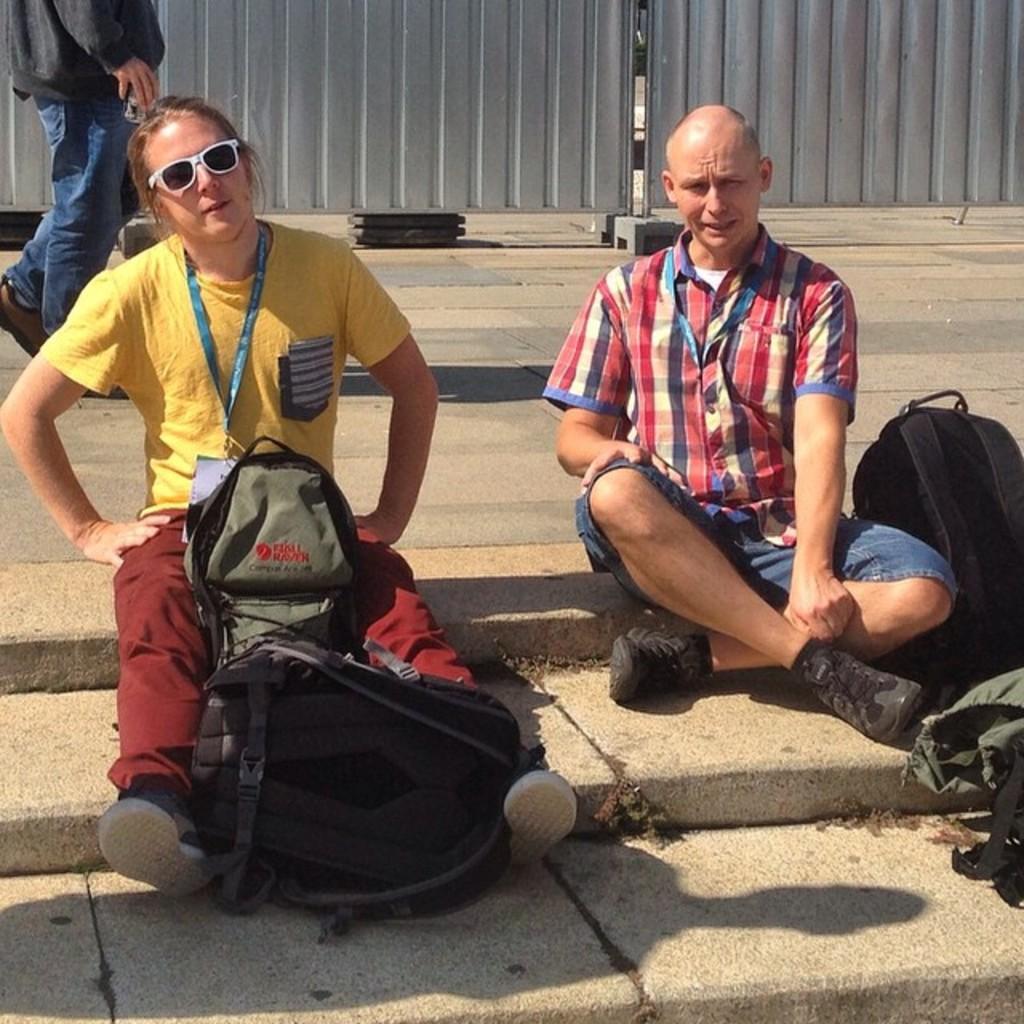Could you give a brief overview of what you see in this image? In this picture we can see two persons sitting on the floor. These are the bags. She has goggles. And on the background we can see a person walking on the road. 